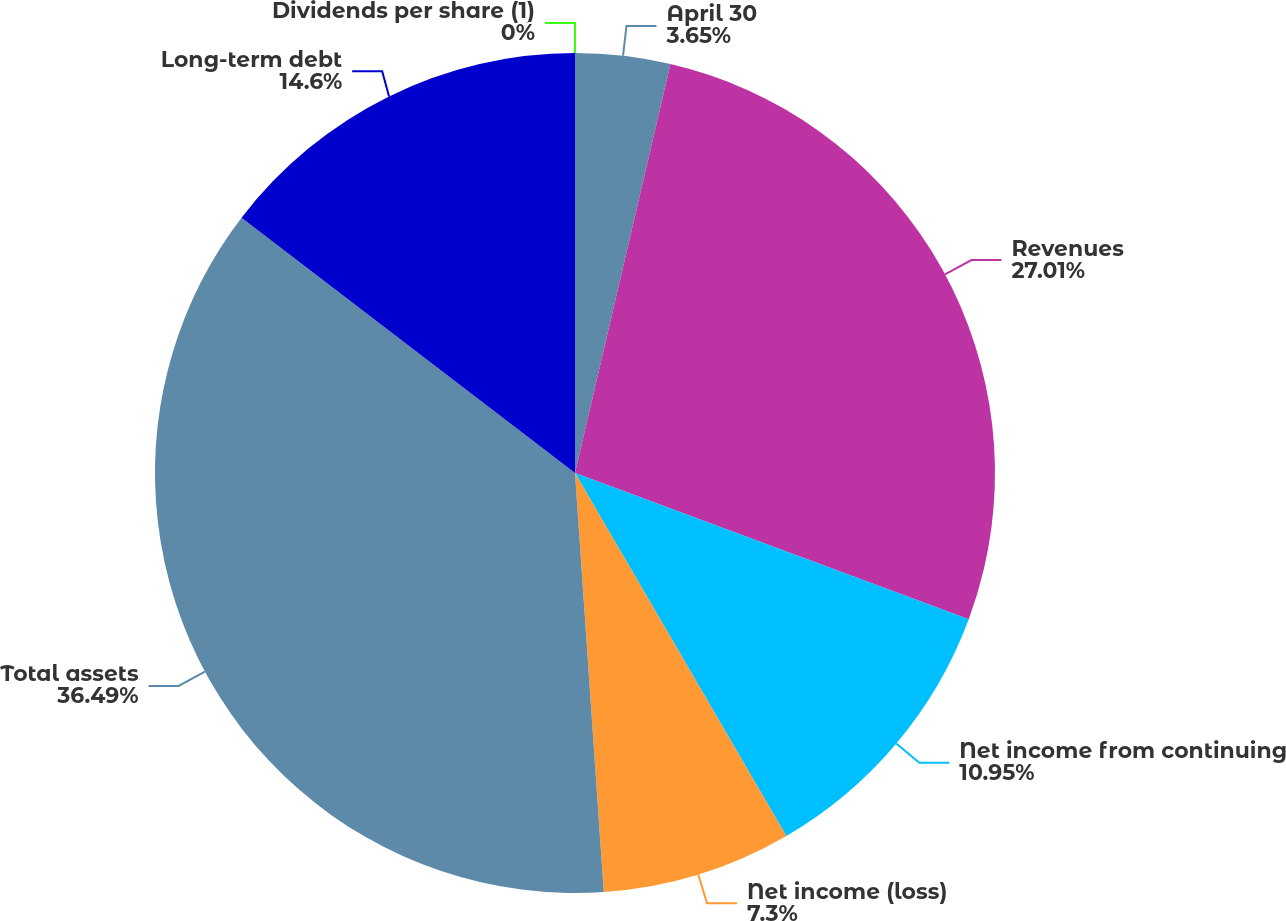Convert chart. <chart><loc_0><loc_0><loc_500><loc_500><pie_chart><fcel>April 30<fcel>Revenues<fcel>Net income from continuing<fcel>Net income (loss)<fcel>Total assets<fcel>Long-term debt<fcel>Dividends per share (1)<nl><fcel>3.65%<fcel>27.01%<fcel>10.95%<fcel>7.3%<fcel>36.49%<fcel>14.6%<fcel>0.0%<nl></chart> 